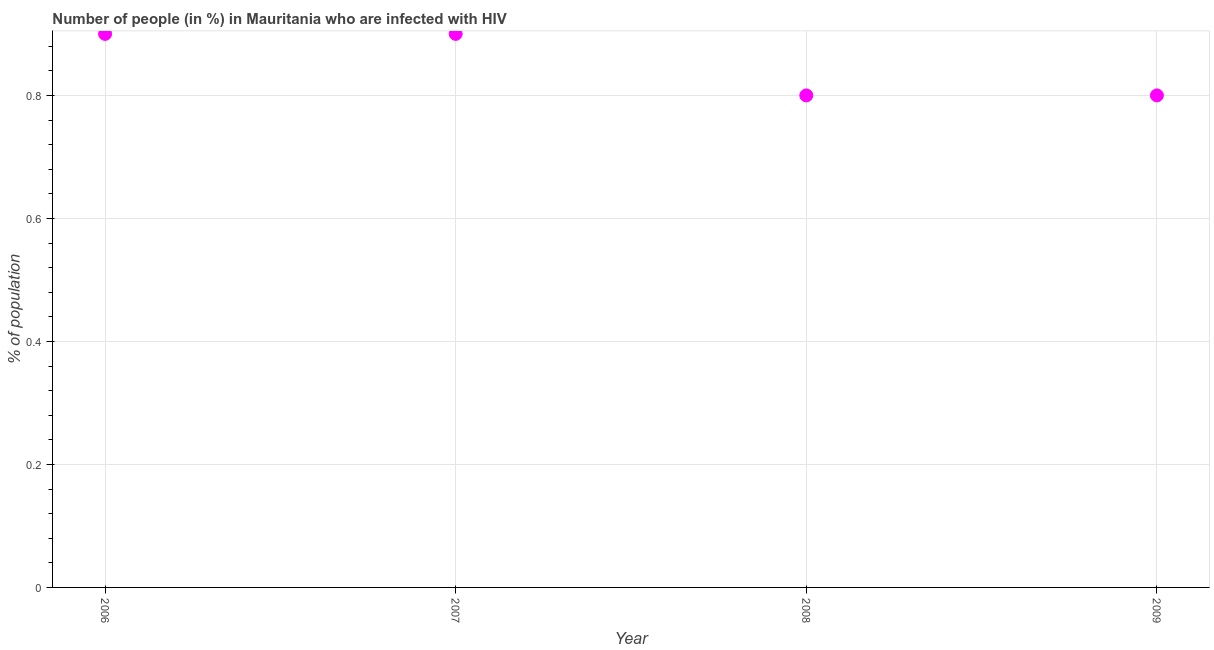In which year was the number of people infected with hiv maximum?
Provide a succinct answer. 2006. In which year was the number of people infected with hiv minimum?
Your answer should be very brief. 2008. What is the sum of the number of people infected with hiv?
Give a very brief answer. 3.4. What is the difference between the number of people infected with hiv in 2008 and 2009?
Make the answer very short. 0. What is the average number of people infected with hiv per year?
Keep it short and to the point. 0.85. What is the median number of people infected with hiv?
Ensure brevity in your answer.  0.85. In how many years, is the number of people infected with hiv greater than 0.04 %?
Give a very brief answer. 4. Do a majority of the years between 2007 and 2006 (inclusive) have number of people infected with hiv greater than 0.44 %?
Make the answer very short. No. What is the ratio of the number of people infected with hiv in 2007 to that in 2008?
Make the answer very short. 1.12. Is the number of people infected with hiv in 2006 less than that in 2009?
Provide a short and direct response. No. Is the sum of the number of people infected with hiv in 2006 and 2007 greater than the maximum number of people infected with hiv across all years?
Your answer should be compact. Yes. What is the difference between the highest and the lowest number of people infected with hiv?
Your answer should be very brief. 0.1. In how many years, is the number of people infected with hiv greater than the average number of people infected with hiv taken over all years?
Keep it short and to the point. 2. What is the difference between two consecutive major ticks on the Y-axis?
Your answer should be very brief. 0.2. What is the title of the graph?
Your answer should be compact. Number of people (in %) in Mauritania who are infected with HIV. What is the label or title of the X-axis?
Your answer should be compact. Year. What is the label or title of the Y-axis?
Make the answer very short. % of population. What is the % of population in 2008?
Provide a succinct answer. 0.8. What is the difference between the % of population in 2006 and 2007?
Provide a short and direct response. 0. What is the difference between the % of population in 2006 and 2008?
Provide a succinct answer. 0.1. What is the difference between the % of population in 2006 and 2009?
Provide a succinct answer. 0.1. What is the difference between the % of population in 2007 and 2008?
Your answer should be very brief. 0.1. What is the ratio of the % of population in 2006 to that in 2008?
Make the answer very short. 1.12. What is the ratio of the % of population in 2008 to that in 2009?
Keep it short and to the point. 1. 